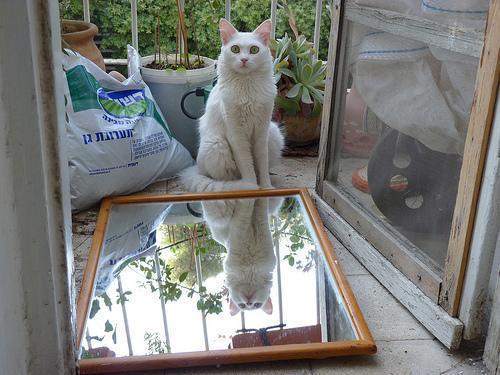How many mirrors are there?
Give a very brief answer. 1. 